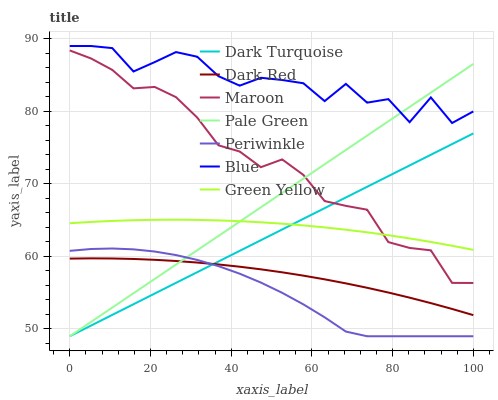Does Periwinkle have the minimum area under the curve?
Answer yes or no. Yes. Does Blue have the maximum area under the curve?
Answer yes or no. Yes. Does Dark Turquoise have the minimum area under the curve?
Answer yes or no. No. Does Dark Turquoise have the maximum area under the curve?
Answer yes or no. No. Is Pale Green the smoothest?
Answer yes or no. Yes. Is Blue the roughest?
Answer yes or no. Yes. Is Dark Turquoise the smoothest?
Answer yes or no. No. Is Dark Turquoise the roughest?
Answer yes or no. No. Does Maroon have the lowest value?
Answer yes or no. No. Does Blue have the highest value?
Answer yes or no. Yes. Does Dark Turquoise have the highest value?
Answer yes or no. No. Is Periwinkle less than Blue?
Answer yes or no. Yes. Is Maroon greater than Periwinkle?
Answer yes or no. Yes. Does Maroon intersect Green Yellow?
Answer yes or no. Yes. Is Maroon less than Green Yellow?
Answer yes or no. No. Is Maroon greater than Green Yellow?
Answer yes or no. No. Does Periwinkle intersect Blue?
Answer yes or no. No. 